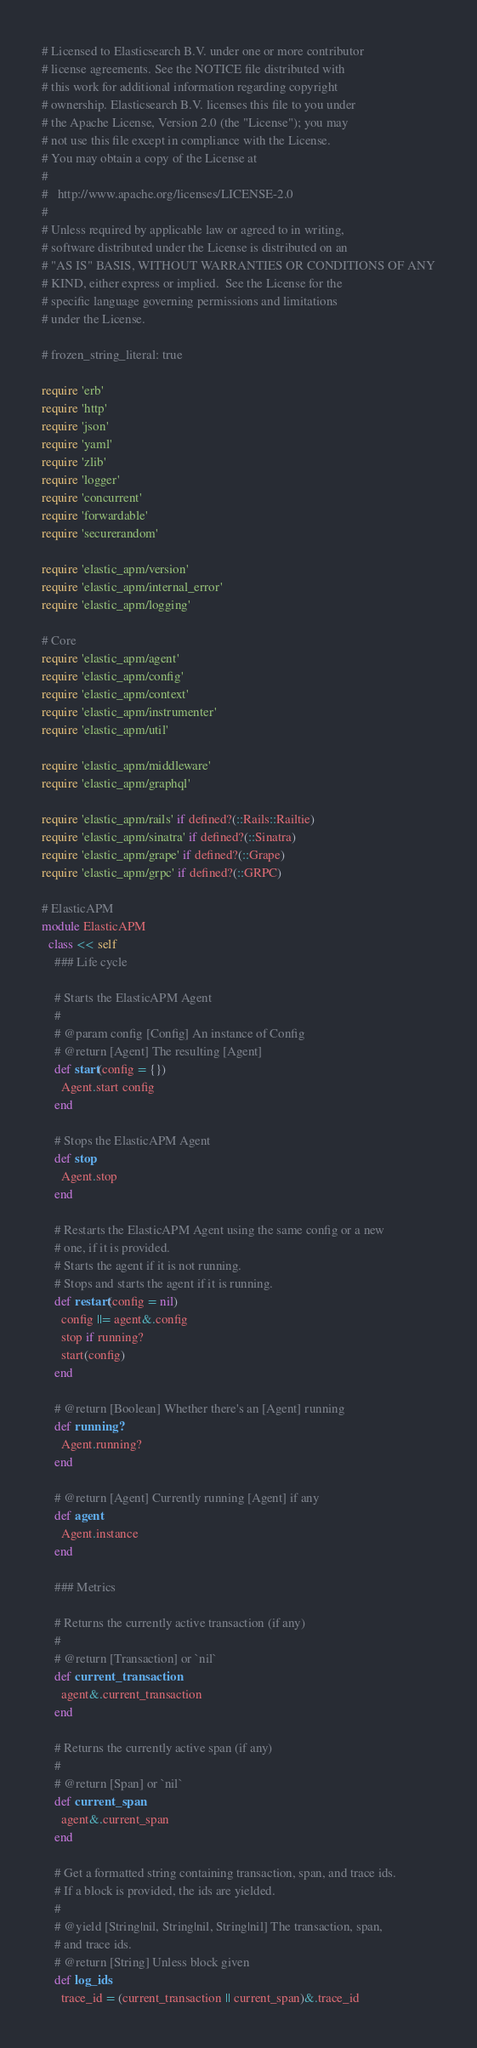<code> <loc_0><loc_0><loc_500><loc_500><_Ruby_># Licensed to Elasticsearch B.V. under one or more contributor
# license agreements. See the NOTICE file distributed with
# this work for additional information regarding copyright
# ownership. Elasticsearch B.V. licenses this file to you under
# the Apache License, Version 2.0 (the "License"); you may
# not use this file except in compliance with the License.
# You may obtain a copy of the License at
#
#   http://www.apache.org/licenses/LICENSE-2.0
#
# Unless required by applicable law or agreed to in writing,
# software distributed under the License is distributed on an
# "AS IS" BASIS, WITHOUT WARRANTIES OR CONDITIONS OF ANY
# KIND, either express or implied.  See the License for the
# specific language governing permissions and limitations
# under the License.

# frozen_string_literal: true

require 'erb'
require 'http'
require 'json'
require 'yaml'
require 'zlib'
require 'logger'
require 'concurrent'
require 'forwardable'
require 'securerandom'

require 'elastic_apm/version'
require 'elastic_apm/internal_error'
require 'elastic_apm/logging'

# Core
require 'elastic_apm/agent'
require 'elastic_apm/config'
require 'elastic_apm/context'
require 'elastic_apm/instrumenter'
require 'elastic_apm/util'

require 'elastic_apm/middleware'
require 'elastic_apm/graphql'

require 'elastic_apm/rails' if defined?(::Rails::Railtie)
require 'elastic_apm/sinatra' if defined?(::Sinatra)
require 'elastic_apm/grape' if defined?(::Grape)
require 'elastic_apm/grpc' if defined?(::GRPC)

# ElasticAPM
module ElasticAPM
  class << self
    ### Life cycle

    # Starts the ElasticAPM Agent
    #
    # @param config [Config] An instance of Config
    # @return [Agent] The resulting [Agent]
    def start(config = {})
      Agent.start config
    end

    # Stops the ElasticAPM Agent
    def stop
      Agent.stop
    end

    # Restarts the ElasticAPM Agent using the same config or a new
    # one, if it is provided.
    # Starts the agent if it is not running.
    # Stops and starts the agent if it is running.
    def restart(config = nil)
      config ||= agent&.config
      stop if running?
      start(config)
    end

    # @return [Boolean] Whether there's an [Agent] running
    def running?
      Agent.running?
    end

    # @return [Agent] Currently running [Agent] if any
    def agent
      Agent.instance
    end

    ### Metrics

    # Returns the currently active transaction (if any)
    #
    # @return [Transaction] or `nil`
    def current_transaction
      agent&.current_transaction
    end

    # Returns the currently active span (if any)
    #
    # @return [Span] or `nil`
    def current_span
      agent&.current_span
    end

    # Get a formatted string containing transaction, span, and trace ids.
    # If a block is provided, the ids are yielded.
    #
    # @yield [String|nil, String|nil, String|nil] The transaction, span,
    # and trace ids.
    # @return [String] Unless block given
    def log_ids
      trace_id = (current_transaction || current_span)&.trace_id</code> 